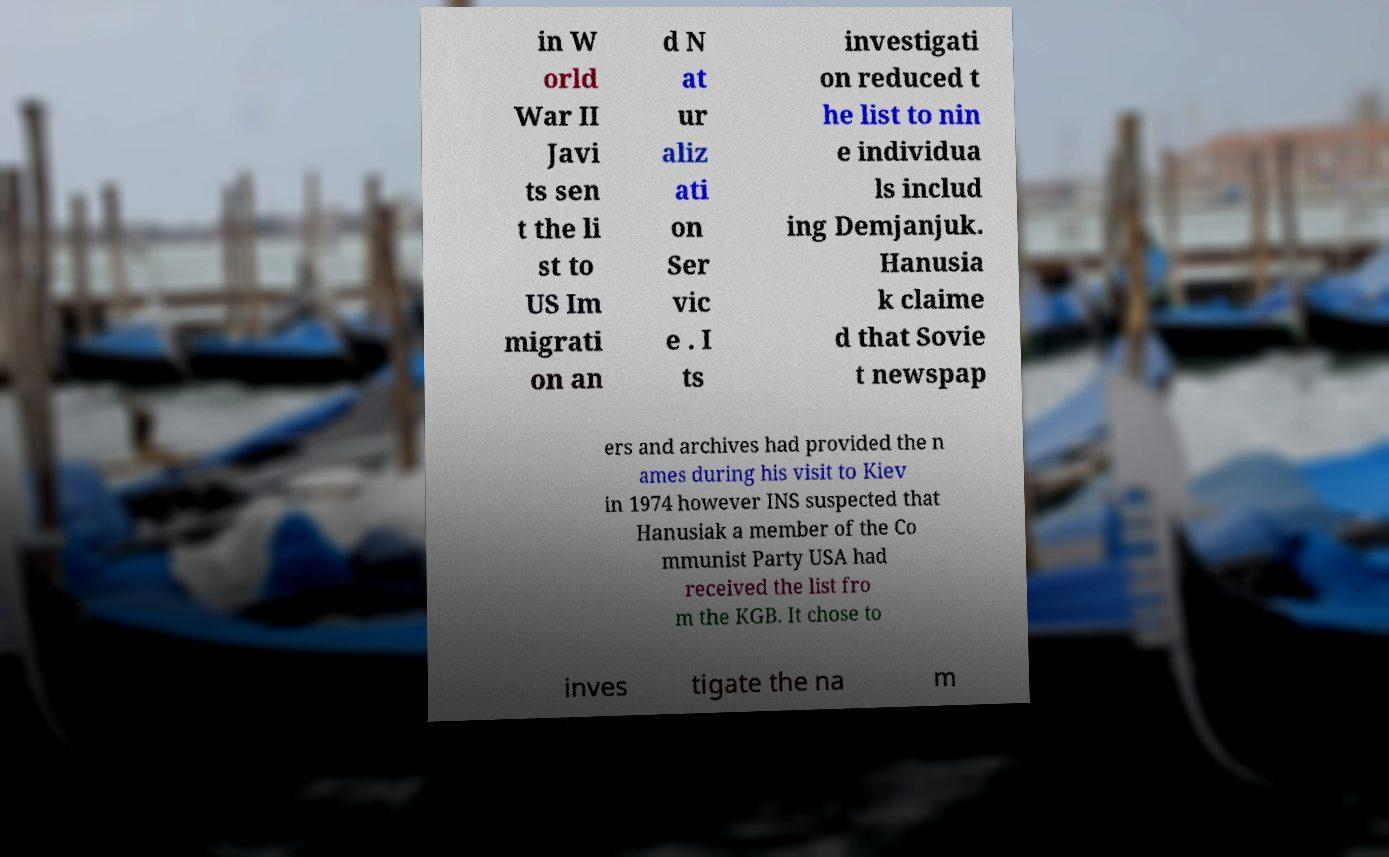Can you accurately transcribe the text from the provided image for me? in W orld War II Javi ts sen t the li st to US Im migrati on an d N at ur aliz ati on Ser vic e . I ts investigati on reduced t he list to nin e individua ls includ ing Demjanjuk. Hanusia k claime d that Sovie t newspap ers and archives had provided the n ames during his visit to Kiev in 1974 however INS suspected that Hanusiak a member of the Co mmunist Party USA had received the list fro m the KGB. It chose to inves tigate the na m 